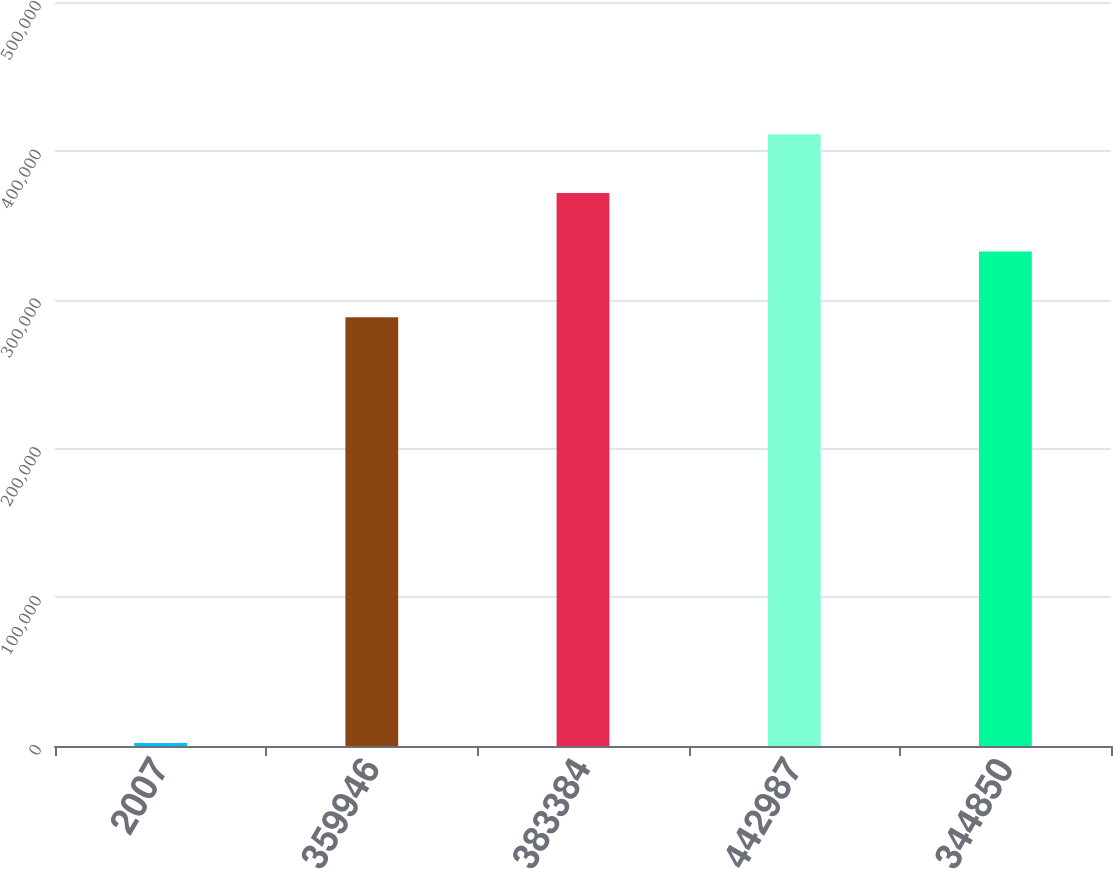<chart> <loc_0><loc_0><loc_500><loc_500><bar_chart><fcel>2007<fcel>359946<fcel>383384<fcel>442987<fcel>344850<nl><fcel>2006<fcel>288131<fcel>371697<fcel>411153<fcel>332242<nl></chart> 